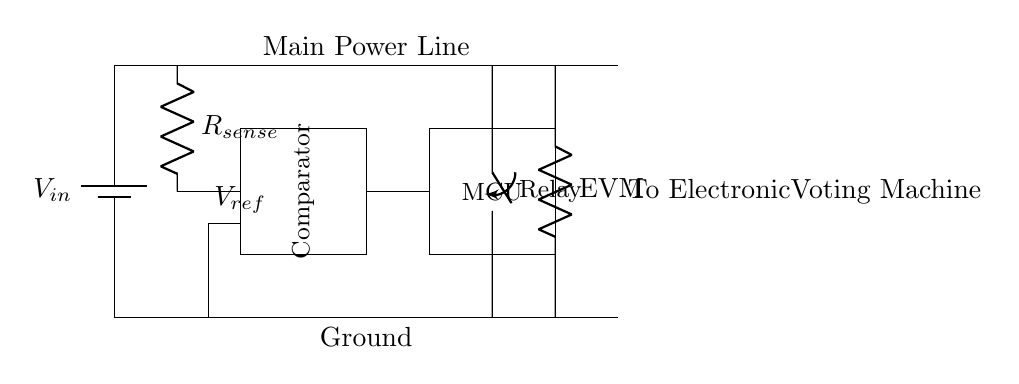What is the function of the comparator in this circuit? The comparator compares the voltage across the current sensing resistor with the reference voltage to determine if the current is too high. If it is, it sends a signal to the microcontroller to activate the relay.
Answer: Comparator What is the value represented by R_sense in this diagram? R_sense represents the current-sensing resistor whose value is not specified in the diagram but is critical for monitoring the current flowing through the circuit for overcurrent protection.
Answer: Current sensing resistor What activates the relay in this circuit? The relay is activated by the microcontroller based on the output of the comparator, which indicates whether the sensed current exceeds a predefined threshold.
Answer: Microcontroller output What does EVM stand for in the circuit? EVM stands for Electronic Voting Machine, which is the load that this circuit is designed to protect from overcurrent conditions.
Answer: Electronic Voting Machine How many main components are there in this protection circuit? The main components identifiable in the diagram include a battery, current sensing resistor, comparator, microcontroller, relay, and load, totaling six main components.
Answer: Six What is the role of the main power line in this circuit? The main power line provides the necessary input voltage to the entire circuit, powering all its components including the load which is the Electronic Voting Machine.
Answer: Power supply What happens if the sensed current exceeds the reference voltage? If the sensed current exceeds the reference voltage, the comparator triggers the microcontroller, which then activates the relay to disconnect power from the Electronic Voting Machine, protecting it from damage.
Answer: Disconnect power 